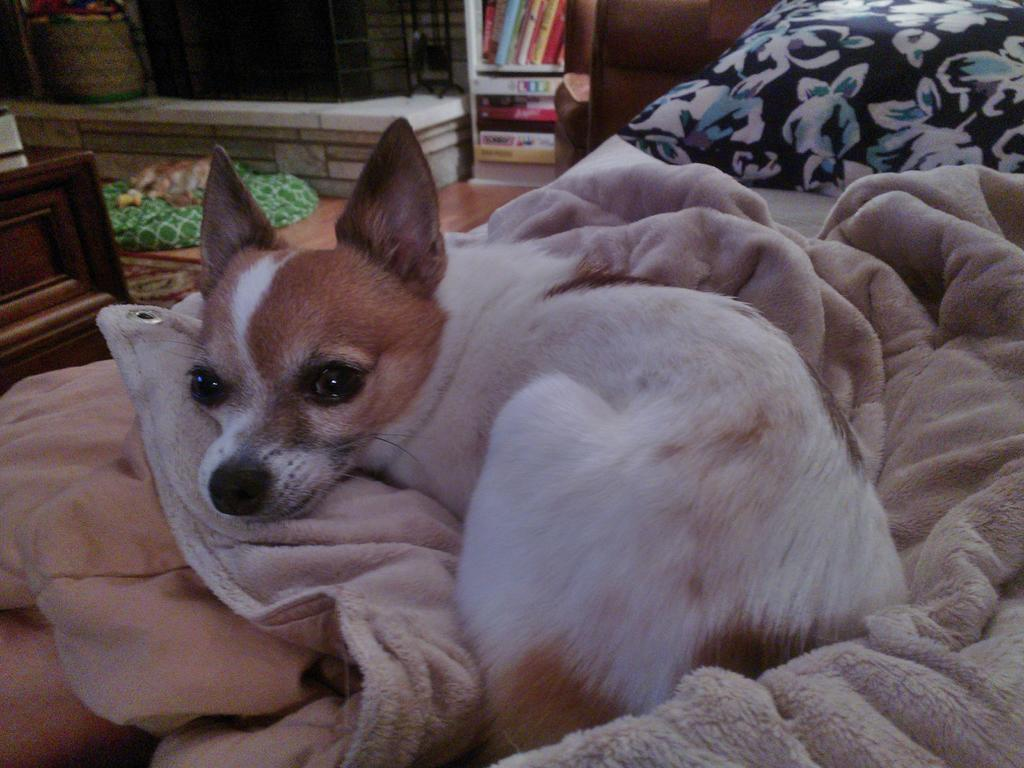What animal is on the bed in the image? There is a dog on the bed in the image. What type of bedding is present on the bed? There is a blanket on the bed. What else is on the bed besides the dog and blanket? There is a pillow on the bed. What can be seen below the bed in the image? The floor is visible in the image. Can you describe any objects present in the image? There are objects present in the image, but their specific details are not mentioned in the provided facts. What type of mask is the dog wearing in the image? There is no mask present on the dog in the image. What song is the dog singing in the image? Dogs do not sing songs, and there is no indication of a song in the image. 